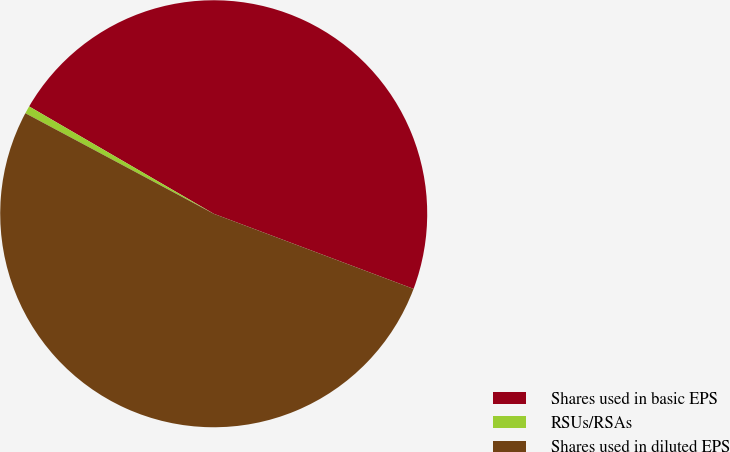<chart> <loc_0><loc_0><loc_500><loc_500><pie_chart><fcel>Shares used in basic EPS<fcel>RSUs/RSAs<fcel>Shares used in diluted EPS<nl><fcel>47.34%<fcel>0.58%<fcel>52.08%<nl></chart> 